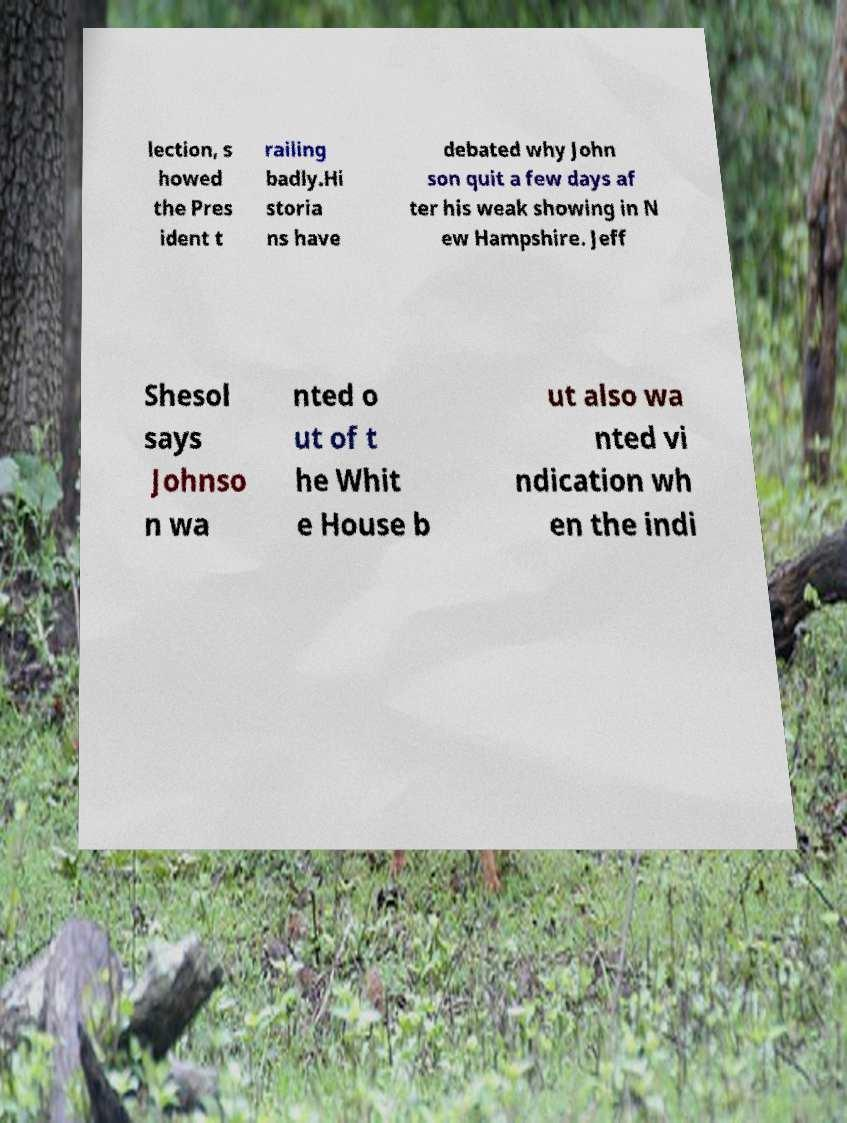Can you read and provide the text displayed in the image?This photo seems to have some interesting text. Can you extract and type it out for me? lection, s howed the Pres ident t railing badly.Hi storia ns have debated why John son quit a few days af ter his weak showing in N ew Hampshire. Jeff Shesol says Johnso n wa nted o ut of t he Whit e House b ut also wa nted vi ndication wh en the indi 